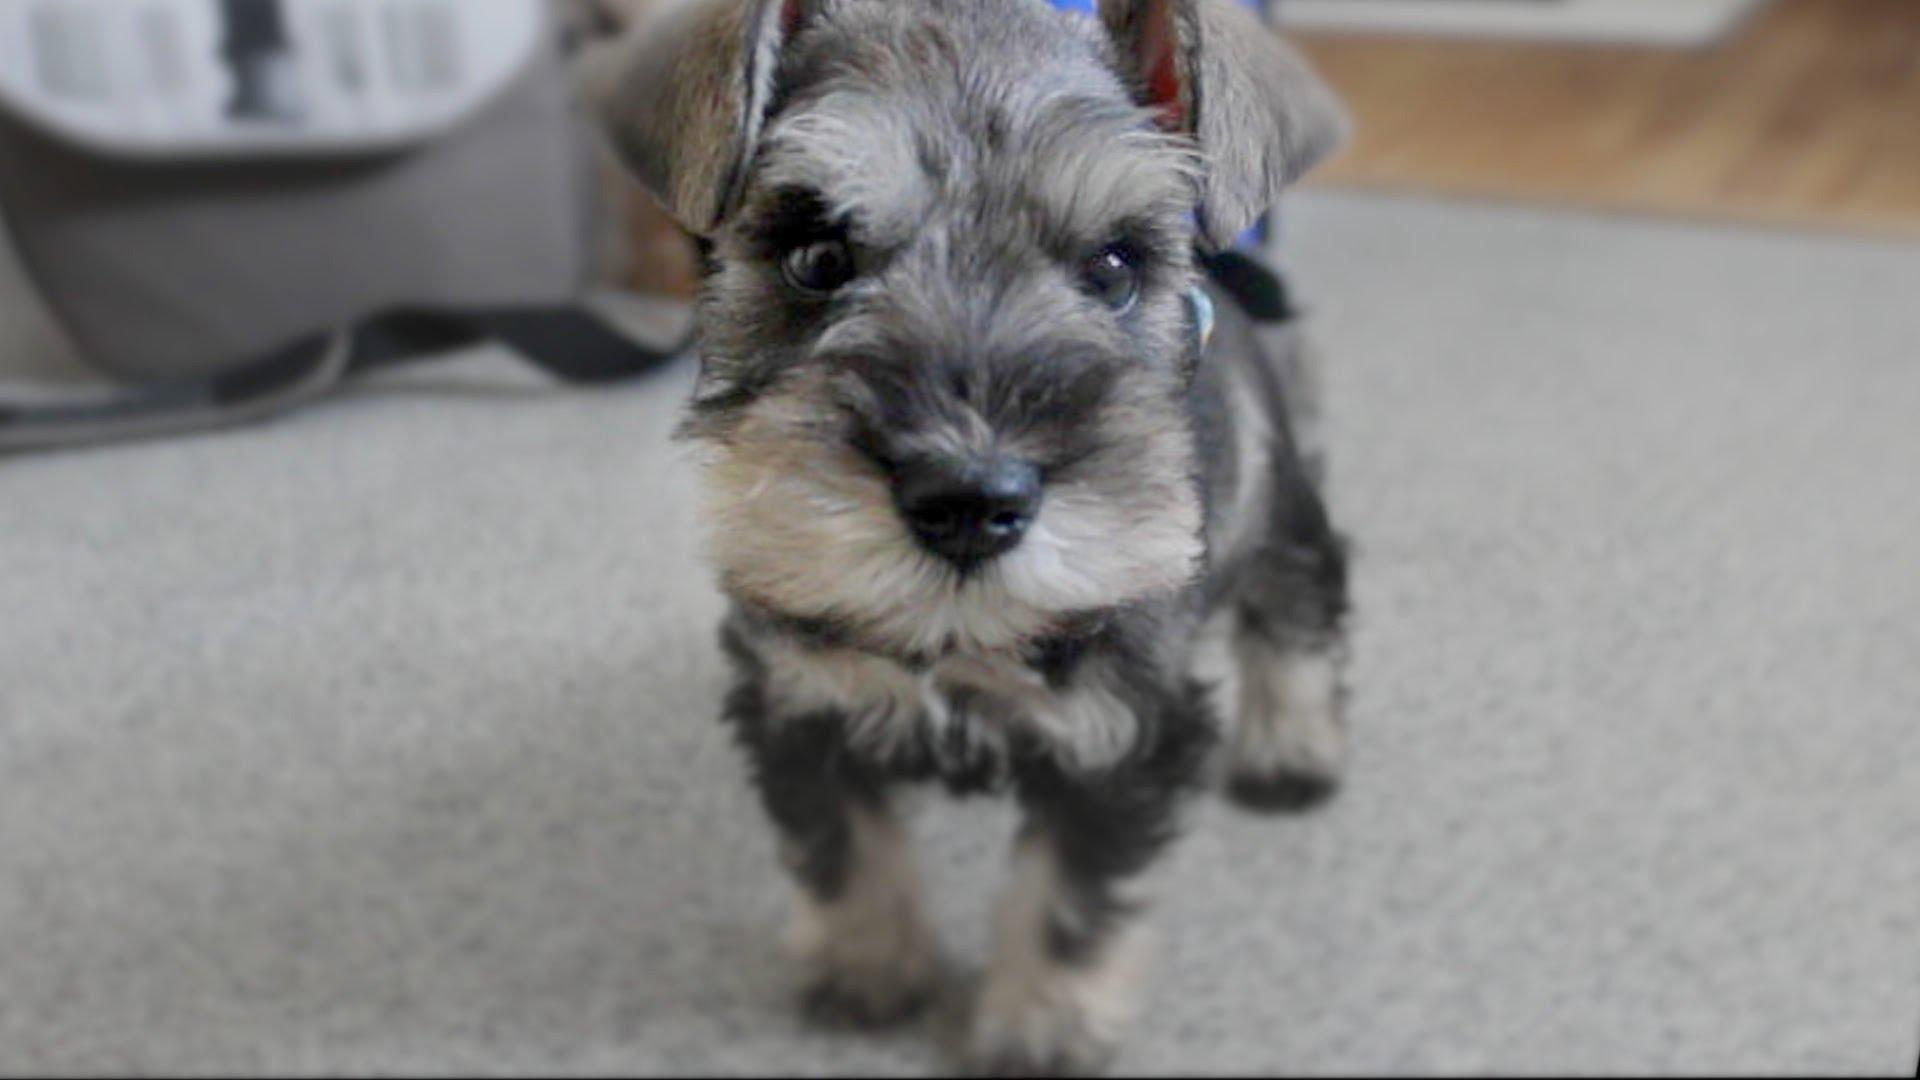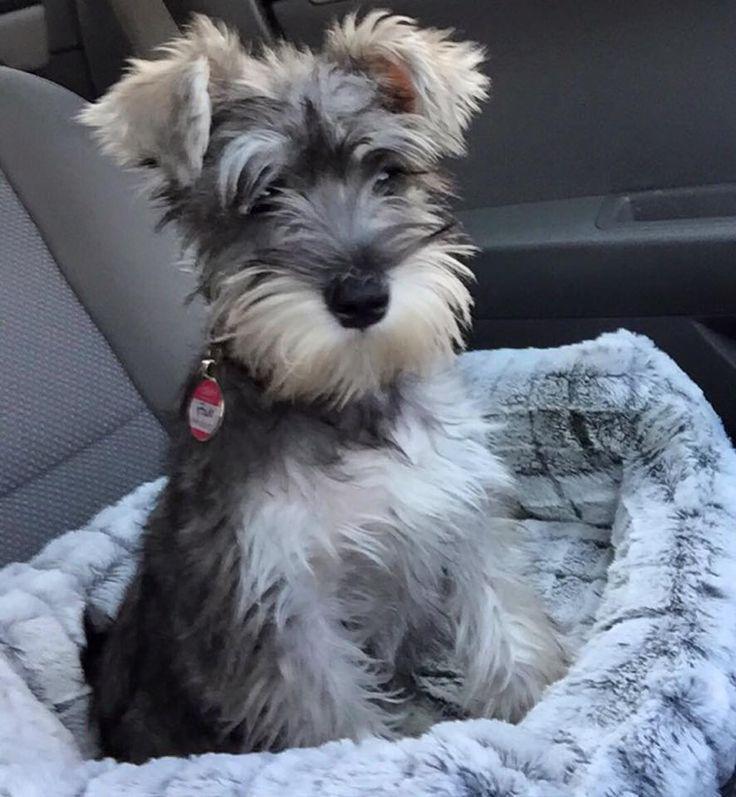The first image is the image on the left, the second image is the image on the right. Given the left and right images, does the statement "There are two dogs inside." hold true? Answer yes or no. Yes. The first image is the image on the left, the second image is the image on the right. Considering the images on both sides, is "There is a colorful dog toy in the image on the right" valid? Answer yes or no. No. 